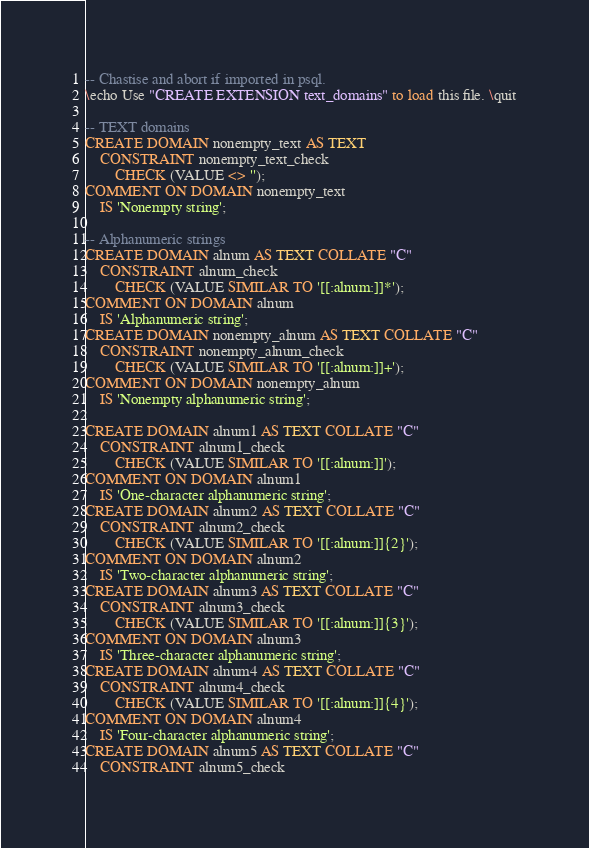<code> <loc_0><loc_0><loc_500><loc_500><_SQL_>-- Chastise and abort if imported in psql.
\echo Use "CREATE EXTENSION text_domains" to load this file. \quit

-- TEXT domains
CREATE DOMAIN nonempty_text AS TEXT
    CONSTRAINT nonempty_text_check
        CHECK (VALUE <> '');
COMMENT ON DOMAIN nonempty_text
    IS 'Nonempty string';

-- Alphanumeric strings
CREATE DOMAIN alnum AS TEXT COLLATE "C"
    CONSTRAINT alnum_check
        CHECK (VALUE SIMILAR TO '[[:alnum:]]*');
COMMENT ON DOMAIN alnum
    IS 'Alphanumeric string';
CREATE DOMAIN nonempty_alnum AS TEXT COLLATE "C"
    CONSTRAINT nonempty_alnum_check
        CHECK (VALUE SIMILAR TO '[[:alnum:]]+');
COMMENT ON DOMAIN nonempty_alnum
    IS 'Nonempty alphanumeric string';

CREATE DOMAIN alnum1 AS TEXT COLLATE "C"
    CONSTRAINT alnum1_check
        CHECK (VALUE SIMILAR TO '[[:alnum:]]');
COMMENT ON DOMAIN alnum1
    IS 'One-character alphanumeric string';
CREATE DOMAIN alnum2 AS TEXT COLLATE "C"
    CONSTRAINT alnum2_check
        CHECK (VALUE SIMILAR TO '[[:alnum:]]{2}');
COMMENT ON DOMAIN alnum2
    IS 'Two-character alphanumeric string';
CREATE DOMAIN alnum3 AS TEXT COLLATE "C"
    CONSTRAINT alnum3_check
        CHECK (VALUE SIMILAR TO '[[:alnum:]]{3}');
COMMENT ON DOMAIN alnum3
    IS 'Three-character alphanumeric string';
CREATE DOMAIN alnum4 AS TEXT COLLATE "C"
    CONSTRAINT alnum4_check
        CHECK (VALUE SIMILAR TO '[[:alnum:]]{4}');
COMMENT ON DOMAIN alnum4
    IS 'Four-character alphanumeric string';
CREATE DOMAIN alnum5 AS TEXT COLLATE "C"
    CONSTRAINT alnum5_check</code> 